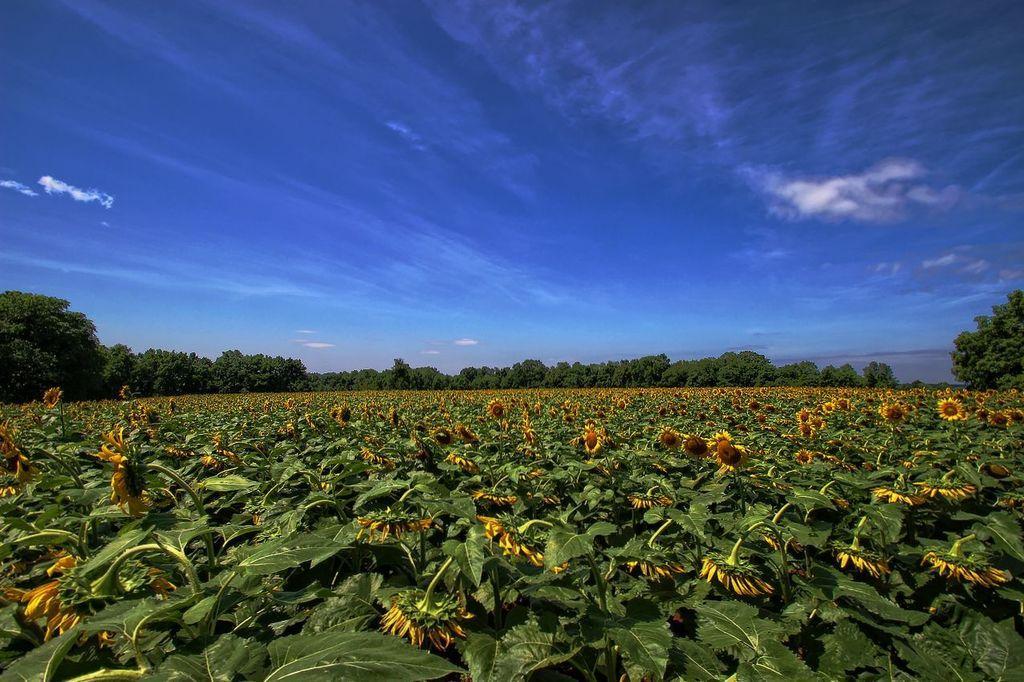Please provide a concise description of this image. In the picture we can see, full of plants with flowers to it and the flowers are yellow in color, in the background, we can see trees around the plants and behind it we can see a sky with clouds. 